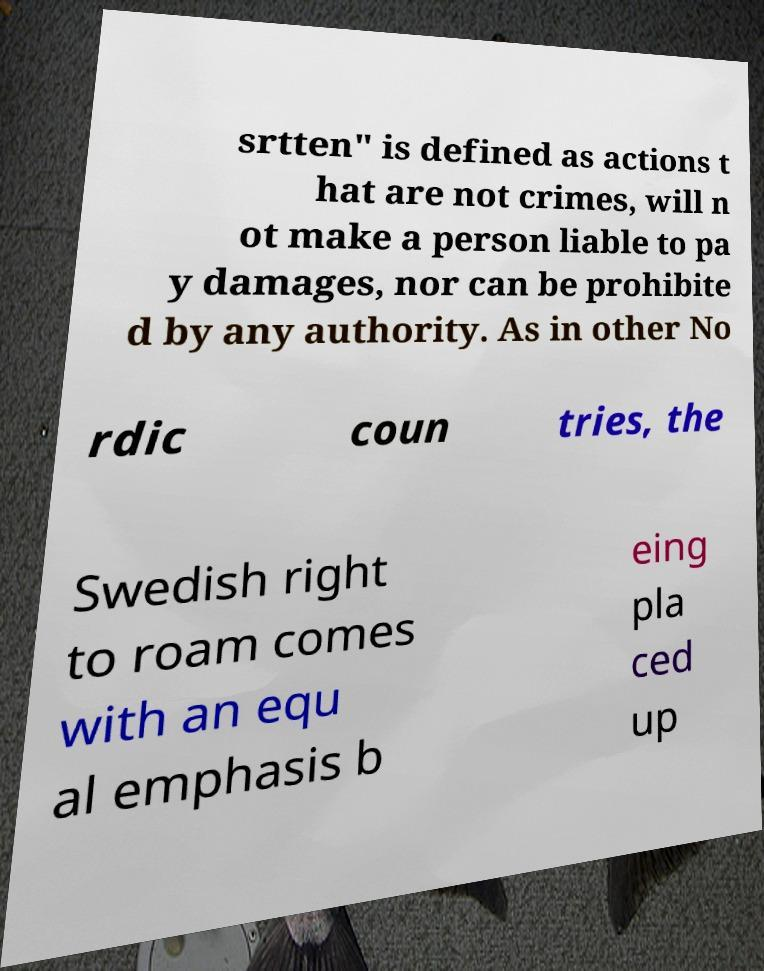Could you extract and type out the text from this image? srtten" is defined as actions t hat are not crimes, will n ot make a person liable to pa y damages, nor can be prohibite d by any authority. As in other No rdic coun tries, the Swedish right to roam comes with an equ al emphasis b eing pla ced up 